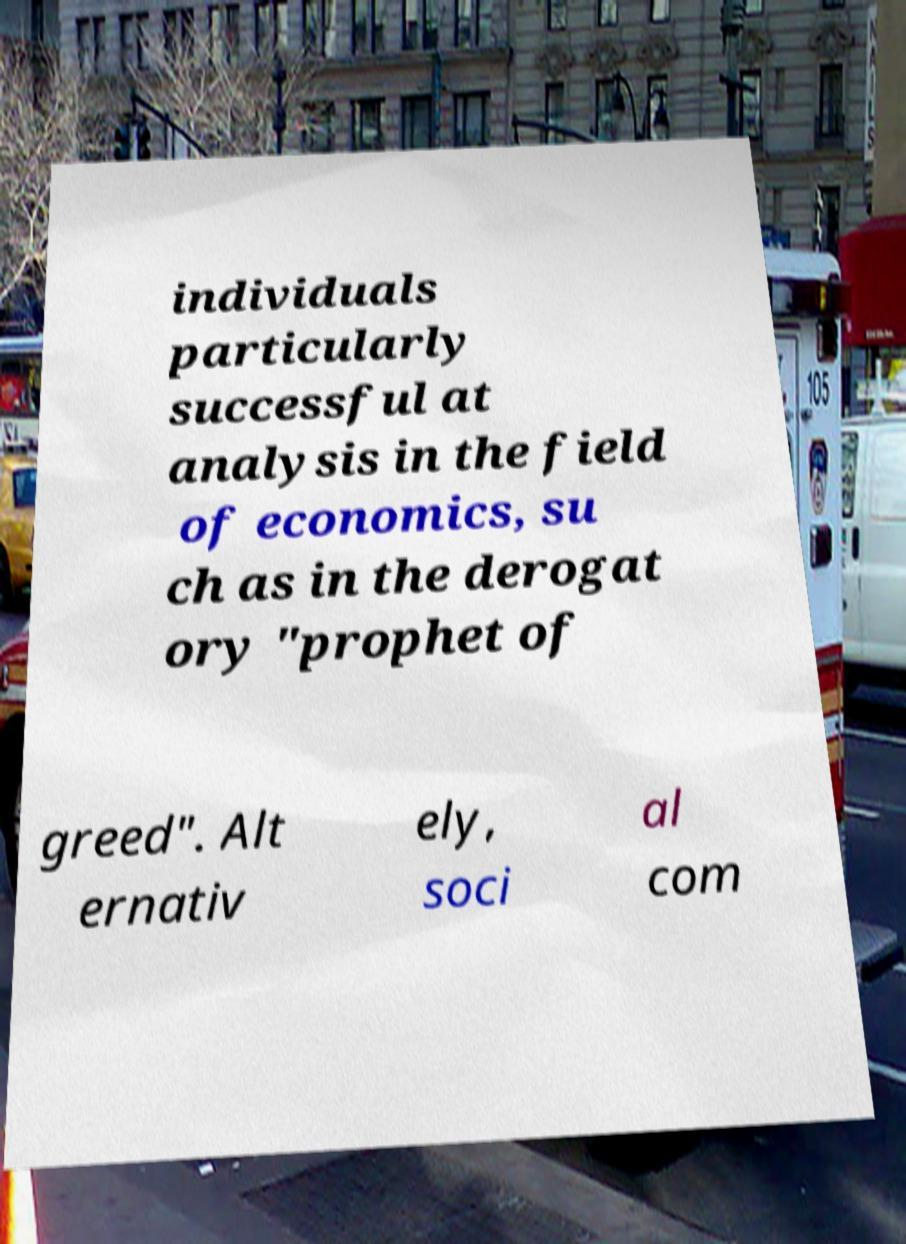Can you accurately transcribe the text from the provided image for me? individuals particularly successful at analysis in the field of economics, su ch as in the derogat ory "prophet of greed". Alt ernativ ely, soci al com 